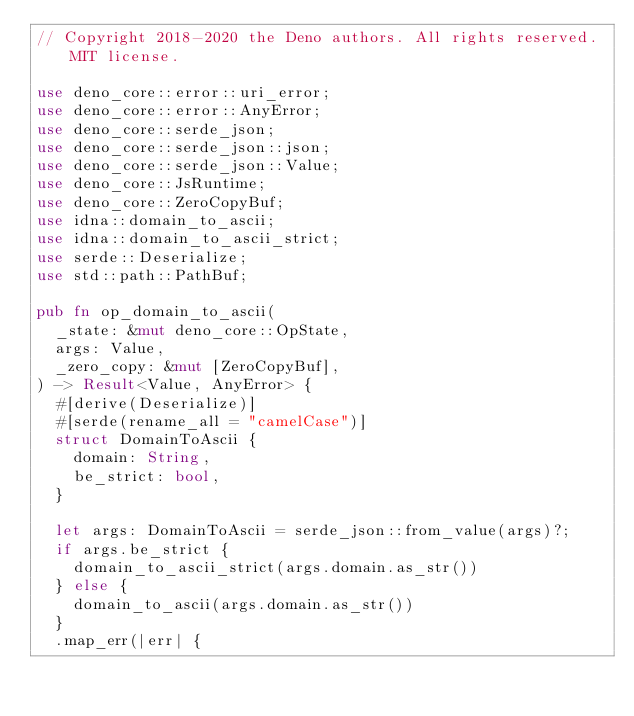<code> <loc_0><loc_0><loc_500><loc_500><_Rust_>// Copyright 2018-2020 the Deno authors. All rights reserved. MIT license.

use deno_core::error::uri_error;
use deno_core::error::AnyError;
use deno_core::serde_json;
use deno_core::serde_json::json;
use deno_core::serde_json::Value;
use deno_core::JsRuntime;
use deno_core::ZeroCopyBuf;
use idna::domain_to_ascii;
use idna::domain_to_ascii_strict;
use serde::Deserialize;
use std::path::PathBuf;

pub fn op_domain_to_ascii(
  _state: &mut deno_core::OpState,
  args: Value,
  _zero_copy: &mut [ZeroCopyBuf],
) -> Result<Value, AnyError> {
  #[derive(Deserialize)]
  #[serde(rename_all = "camelCase")]
  struct DomainToAscii {
    domain: String,
    be_strict: bool,
  }

  let args: DomainToAscii = serde_json::from_value(args)?;
  if args.be_strict {
    domain_to_ascii_strict(args.domain.as_str())
  } else {
    domain_to_ascii(args.domain.as_str())
  }
  .map_err(|err| {</code> 